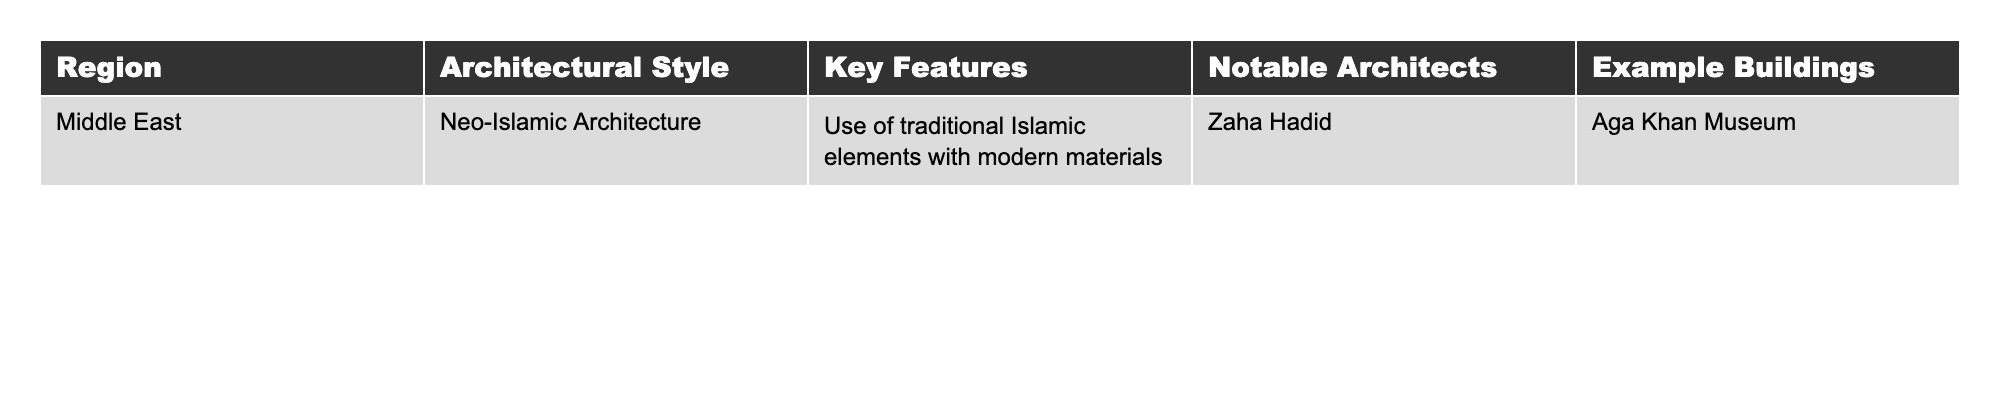What architectural style is represented in the Middle East? The table indicates that Neo-Islamic Architecture is the style for the Middle East.
Answer: Neo-Islamic Architecture Who is a notable architect associated with the Neo-Islamic Architecture style? According to the table, Zaha Hadid is listed as a notable architect for this style.
Answer: Zaha Hadid What is one key feature of Neo-Islamic Architecture? The table states that a key feature is the use of traditional Islamic elements with modern materials.
Answer: Traditional Islamic elements with modern materials Can you name an example building from the Middle East that showcases Neo-Islamic Architecture? The table lists the Aga Khan Museum as an example building of this architectural style in the Middle East.
Answer: Aga Khan Museum Is Zaha Hadid known for any architectural style outside of Neo-Islamic Architecture? The table solely mentions Zaha Hadid in relation to Neo-Islamic Architecture, so it is unclear if she is associated with another style based on this data.
Answer: No What two elements are combined in the Neo-Islamic Architecture style? The table highlights that this style combines traditional Islamic elements with modern materials.
Answer: Traditional Islamic elements and modern materials How many notable architects are mentioned for Neo-Islamic Architecture in this table? The table mentions one notable architect—Zaha Hadid—specifically for Neo-Islamic Architecture in the Middle East.
Answer: One If we were to compare Neo-Islamic Architecture and another style not shown in this table, what key feature might differ significantly? Since the table does not provide information on other architectural styles, one cannot identify a comparative key feature without additional data.
Answer: Not answerable Are there any example buildings provided for architects besides Zaha Hadid in this table? The table only provides information on one architect, Zaha Hadid, and does not mention any other example buildings or architects.
Answer: No What is the primary region discussed in this table for Neo-Islamic Architecture? The primary region mentioned in the table for this architectural style is the Middle East.
Answer: Middle East 